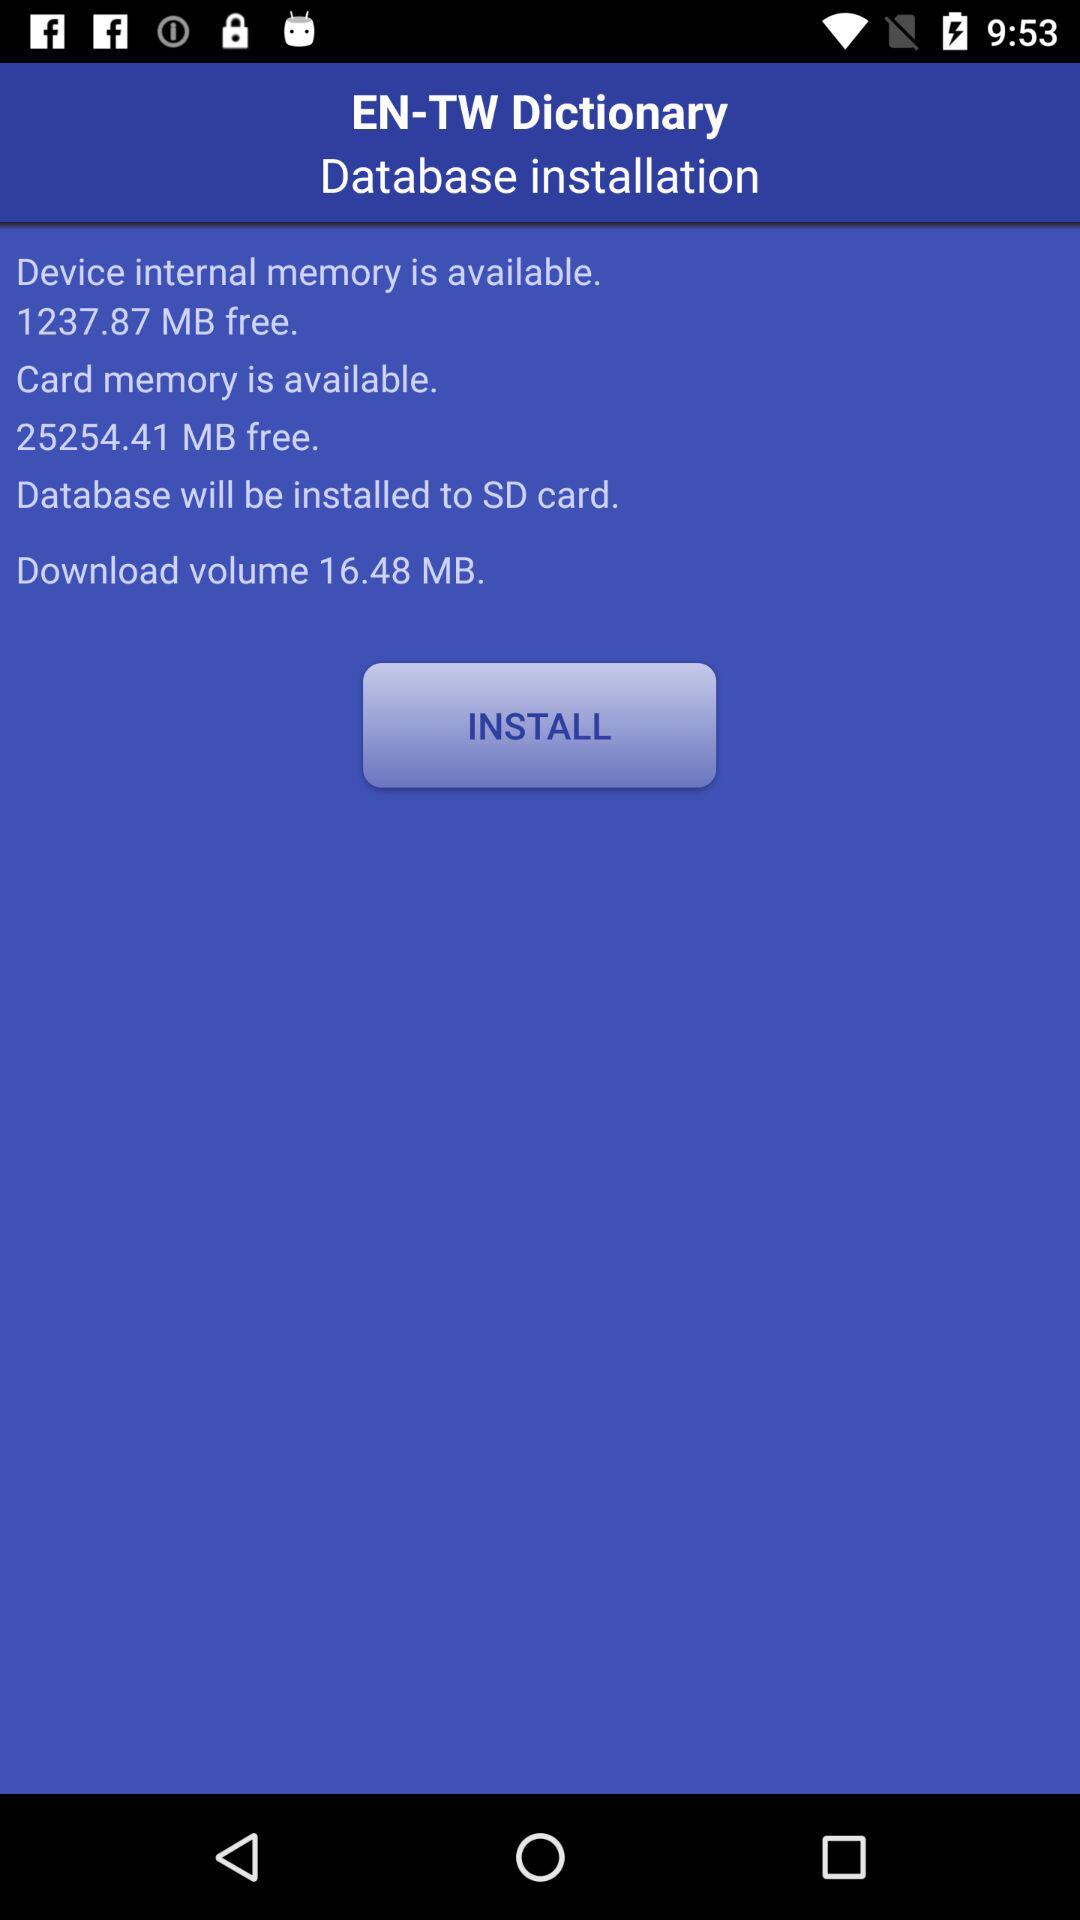Which version of the application is this?
When the provided information is insufficient, respond with <no answer>. <no answer> 